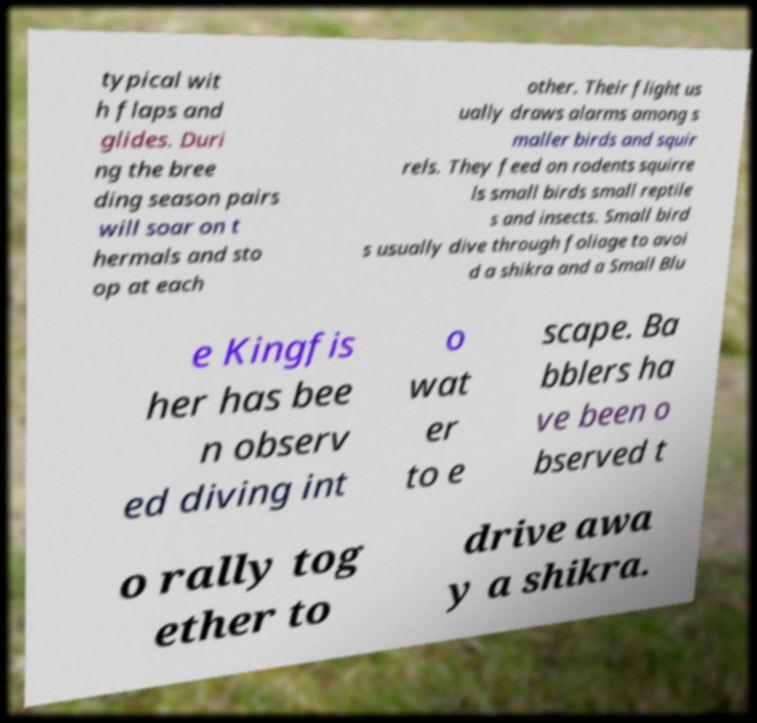Can you accurately transcribe the text from the provided image for me? typical wit h flaps and glides. Duri ng the bree ding season pairs will soar on t hermals and sto op at each other. Their flight us ually draws alarms among s maller birds and squir rels. They feed on rodents squirre ls small birds small reptile s and insects. Small bird s usually dive through foliage to avoi d a shikra and a Small Blu e Kingfis her has bee n observ ed diving int o wat er to e scape. Ba bblers ha ve been o bserved t o rally tog ether to drive awa y a shikra. 